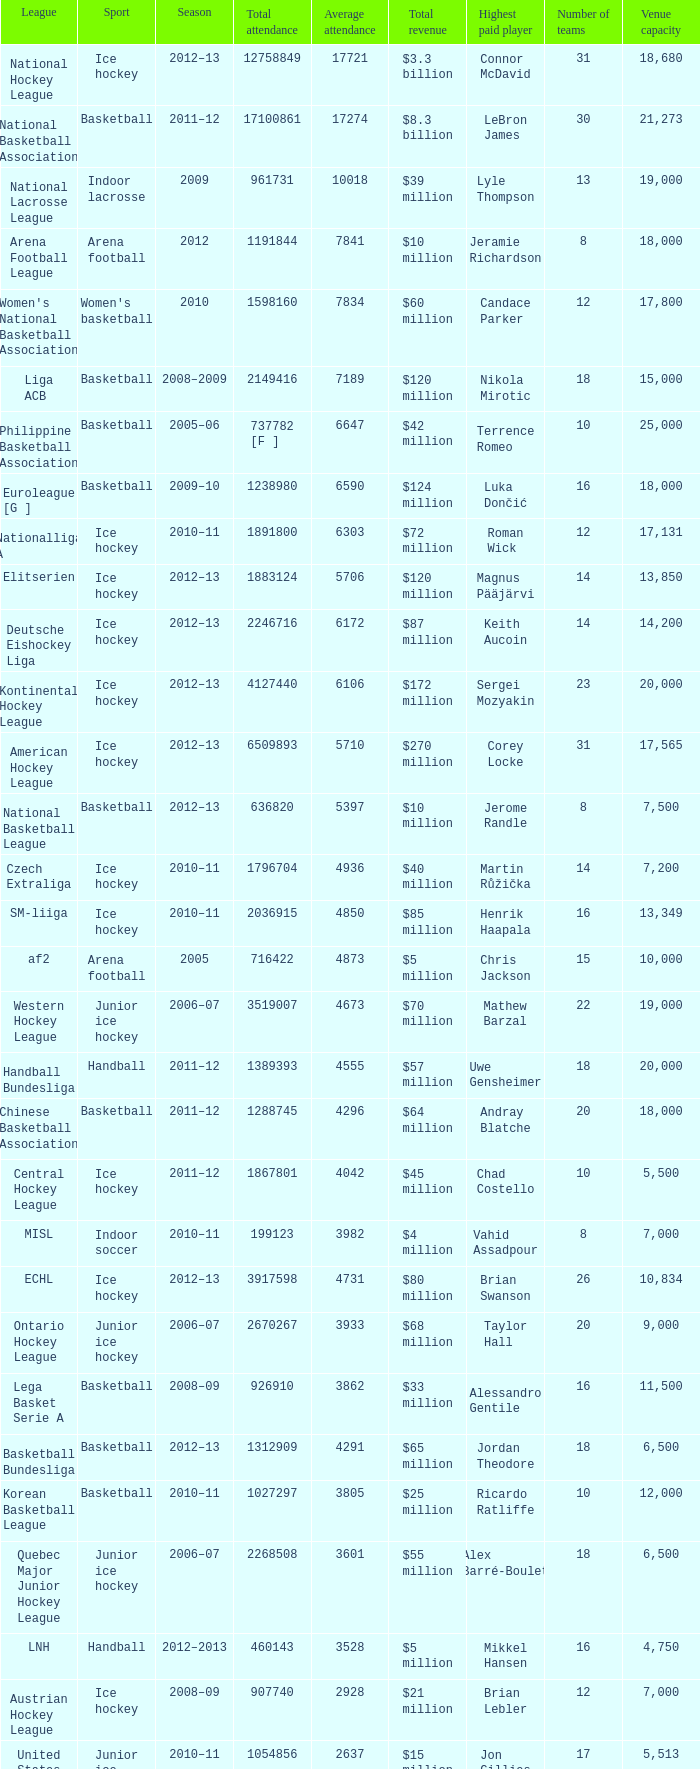What was the highest average attendance in the 2009 season? 10018.0. 